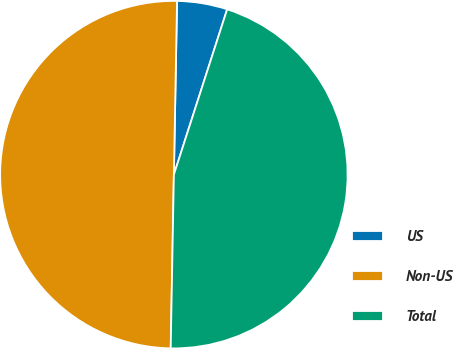Convert chart to OTSL. <chart><loc_0><loc_0><loc_500><loc_500><pie_chart><fcel>US<fcel>Non-US<fcel>Total<nl><fcel>4.67%<fcel>50.0%<fcel>45.33%<nl></chart> 